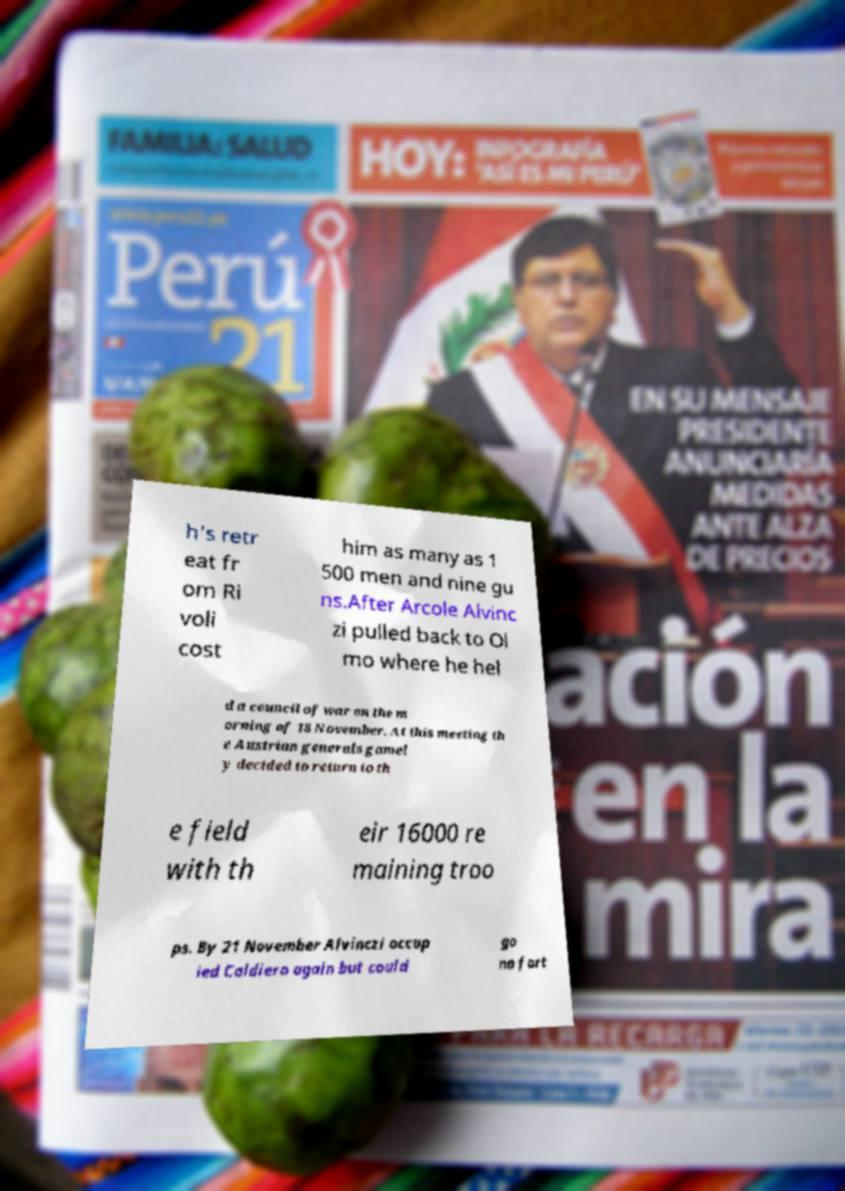What messages or text are displayed in this image? I need them in a readable, typed format. h's retr eat fr om Ri voli cost him as many as 1 500 men and nine gu ns.After Arcole Alvinc zi pulled back to Ol mo where he hel d a council of war on the m orning of 18 November. At this meeting th e Austrian generals gamel y decided to return to th e field with th eir 16000 re maining troo ps. By 21 November Alvinczi occup ied Caldiero again but could go no fart 